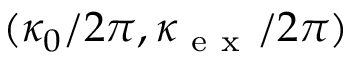<formula> <loc_0><loc_0><loc_500><loc_500>( \kappa _ { 0 } / 2 \pi , \kappa _ { e x } / 2 \pi )</formula> 